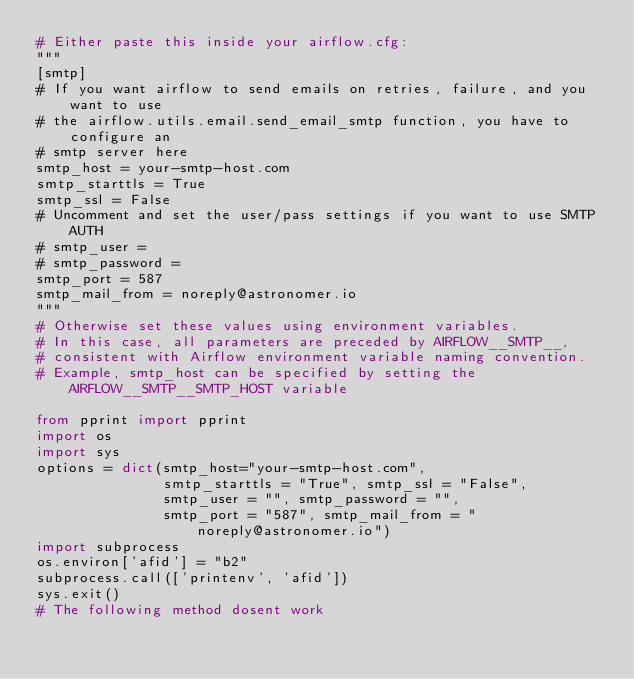Convert code to text. <code><loc_0><loc_0><loc_500><loc_500><_Python_># Either paste this inside your airflow.cfg:
"""
[smtp]
# If you want airflow to send emails on retries, failure, and you want to use
# the airflow.utils.email.send_email_smtp function, you have to configure an
# smtp server here
smtp_host = your-smtp-host.com
smtp_starttls = True
smtp_ssl = False
# Uncomment and set the user/pass settings if you want to use SMTP AUTH
# smtp_user =
# smtp_password =
smtp_port = 587
smtp_mail_from = noreply@astronomer.io
"""
# Otherwise set these values using environment variables.
# In this case, all parameters are preceded by AIRFLOW__SMTP__,
# consistent with Airflow environment variable naming convention.
# Example, smtp_host can be specified by setting the AIRFLOW__SMTP__SMTP_HOST variable

from pprint import pprint
import os
import sys
options = dict(smtp_host="your-smtp-host.com",
               smtp_starttls = "True", smtp_ssl = "False",
               smtp_user = "", smtp_password = "", 
               smtp_port = "587", smtp_mail_from = "noreply@astronomer.io")
import subprocess
os.environ['afid'] = "b2"
subprocess.call(['printenv', 'afid'])
sys.exit()
# The following method dosent work </code> 